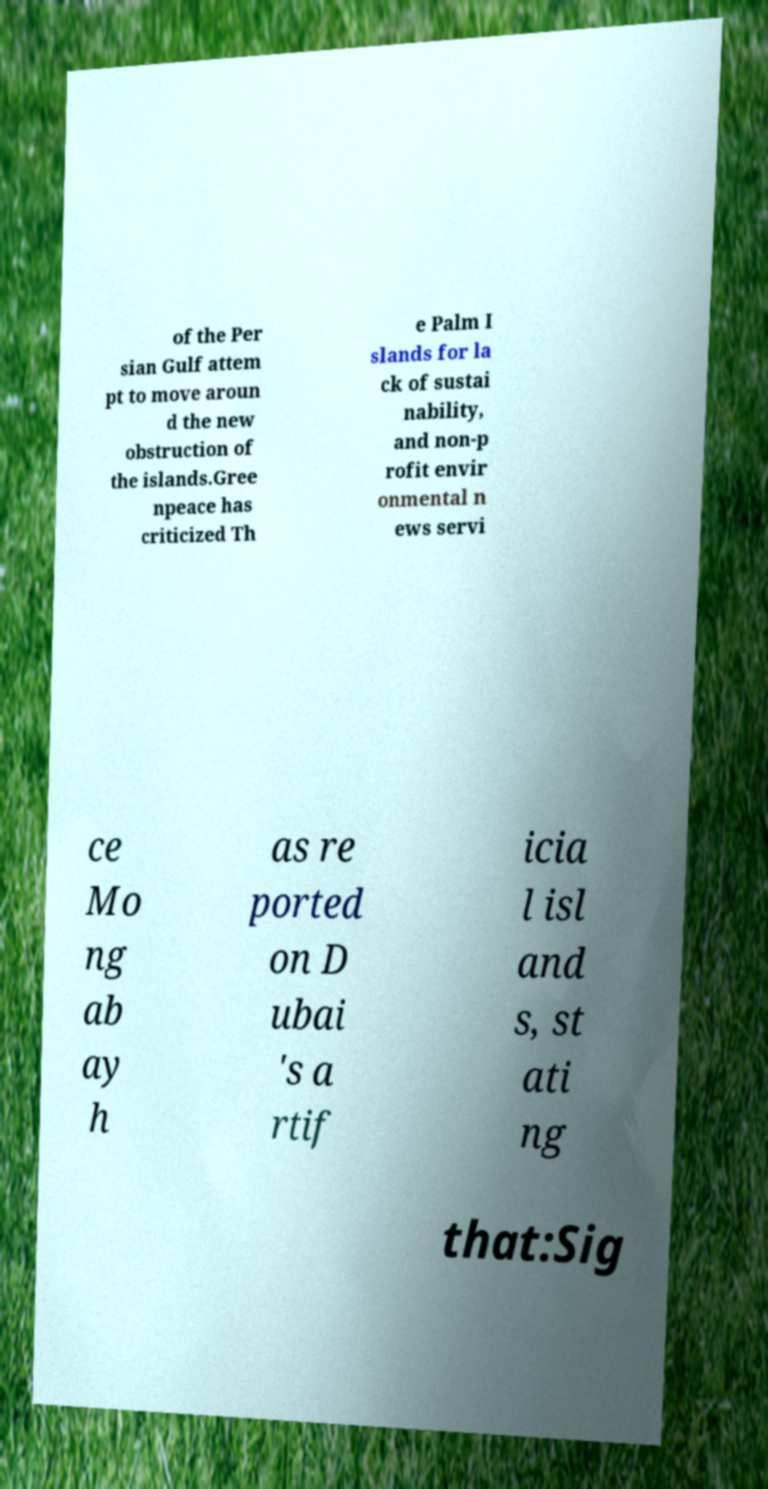Can you accurately transcribe the text from the provided image for me? of the Per sian Gulf attem pt to move aroun d the new obstruction of the islands.Gree npeace has criticized Th e Palm I slands for la ck of sustai nability, and non-p rofit envir onmental n ews servi ce Mo ng ab ay h as re ported on D ubai 's a rtif icia l isl and s, st ati ng that:Sig 